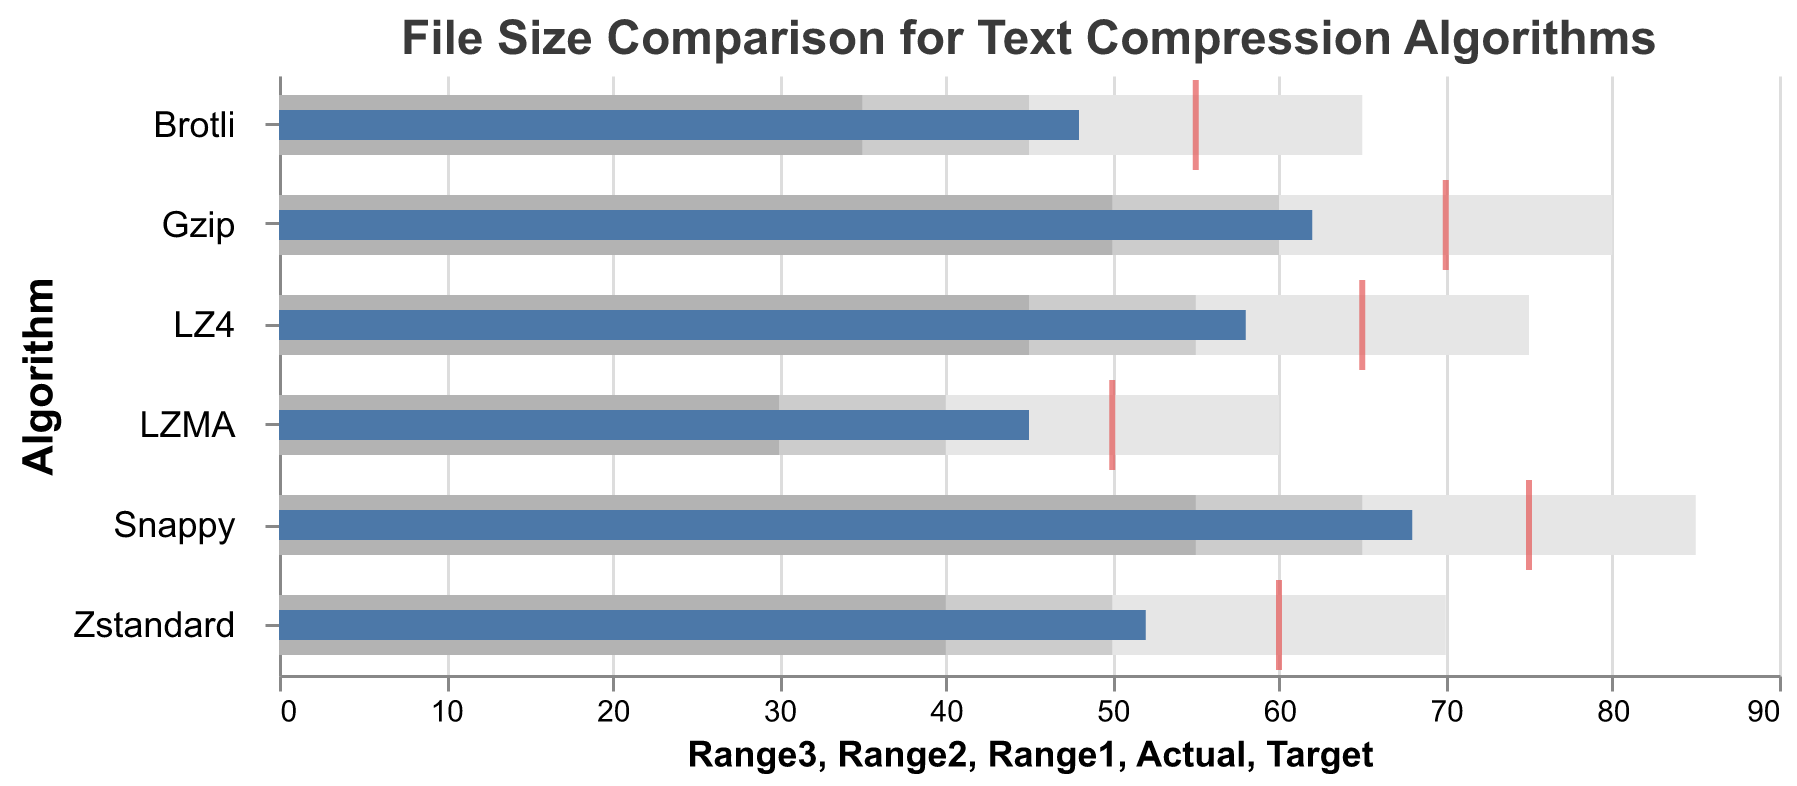What is the title of the figure? The title is located at the top-center of the figure and is "File Size Comparison for Text Compression Algorithms".
Answer: File Size Comparison for Text Compression Algorithms Which text compression algorithm has the lowest actual file size? By examining the bars representing actual file sizes, the shortest bar corresponds to the LZMA algorithm.
Answer: LZMA How far is the actual file size of the Gzip algorithm from its target? The actual file size for Gzip is 62, and the target file size is 70. The difference is 70 - 62 = 8.
Answer: 8 For which algorithm does the actual file size exceed the lower bound of the third range? The lower bound of the third range for each algorithm is equivalent to Range3. Checking each, all algorithms except Snappy fall short of their Range3 lower bound (Gzip: 62 < 80, LZMA: 45 < 60, etc.), but Snappy's actual file size of 68 exceeds its Range3 lower bound of 65.
Answer: Snappy Compare the actual file sizes of Brotli and Zstandard. Which one is higher? The actual file size for Brotli is 48, and for Zstandard, it is 52. Comparing these values, Zstandard has the higher actual file size.
Answer: Zstandard Which algorithm's actual file size meets or exceeds the target size? Checking the actual and target file sizes, none of the algorithms have their actual file size meeting or exceeding the target size.
Answer: None What is the difference between the actual file size and the lowest value in the second range for LZ4? For LZ4, the actual file size is 58, and the second range's lower bound is 45. The difference is 58 - 45 = 13.
Answer: 13 How many algorithms have an actual file size less than 60? Counting the bars representing actual file sizes below 60: LZMA (45), Brotli (48), and Zstandard (52). There are three algorithms that match this criterion.
Answer: 3 Is the actual size for Snappy within its first range? Snappy's actual size is 68, while its first range is 55. Since 68 > 55, the actual size is not within its first range.
Answer: No 